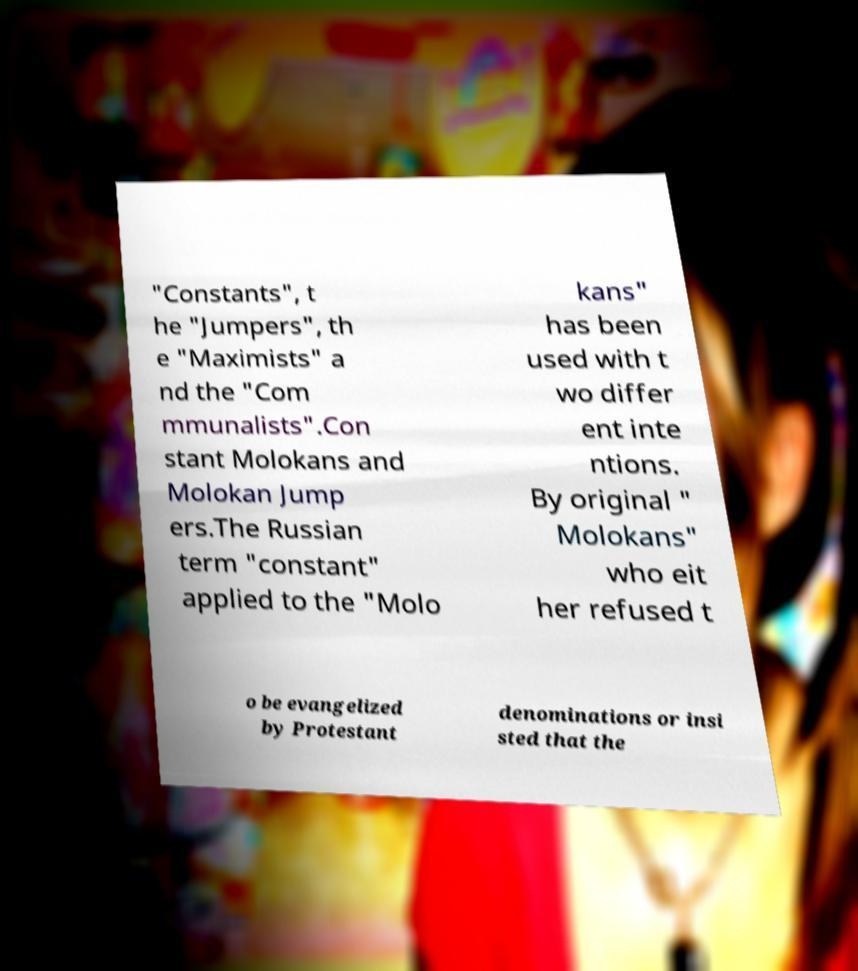Please identify and transcribe the text found in this image. "Constants", t he "Jumpers", th e "Maximists" a nd the "Com mmunalists".Con stant Molokans and Molokan Jump ers.The Russian term "constant" applied to the "Molo kans" has been used with t wo differ ent inte ntions. By original " Molokans" who eit her refused t o be evangelized by Protestant denominations or insi sted that the 